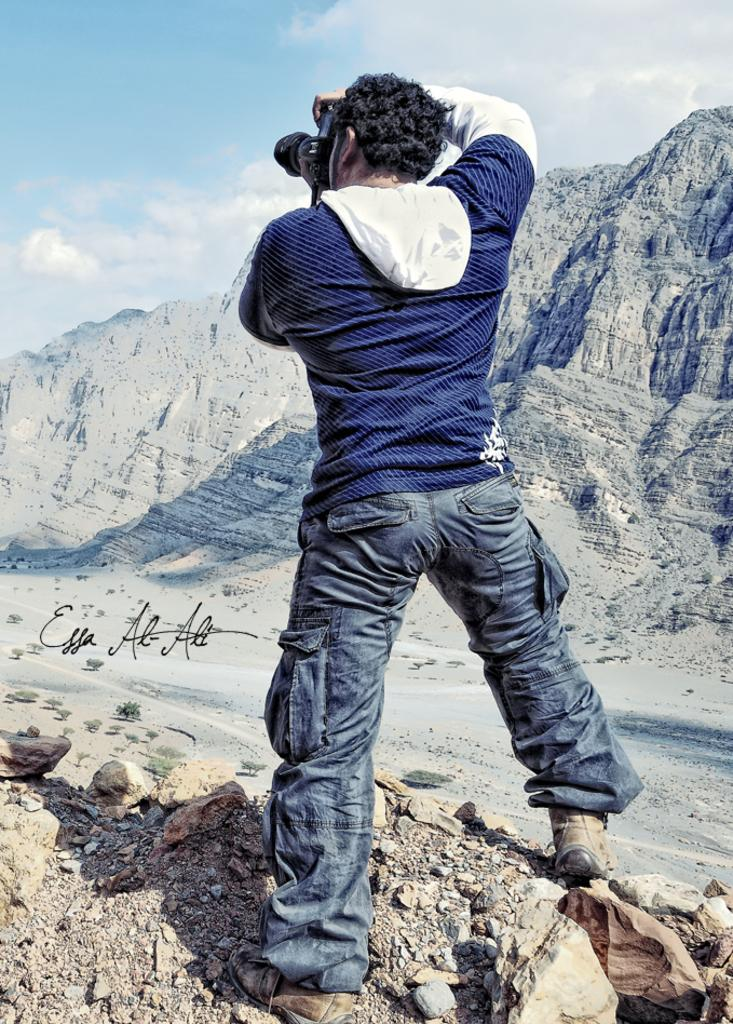What is the main subject in the foreground of the picture? There is a man in the foreground of the picture. What is the man doing in the image? The man is standing in the image. What is the man holding in the picture? The man is holding a camera in the picture. What can be seen in the background of the picture? There are mountains in the background of the picture. What is visible in the sky in the image? The sky is visible in the image, and it is partly cloudy. What is the weather like in the image? It is sunny in the image. What type of spoon can be seen in the man's hand in the image? There is no spoon present in the man's hand or in the image. Can you describe the road conditions in the image? There is no road visible in the image; it features a man standing with a camera in front of mountains. 